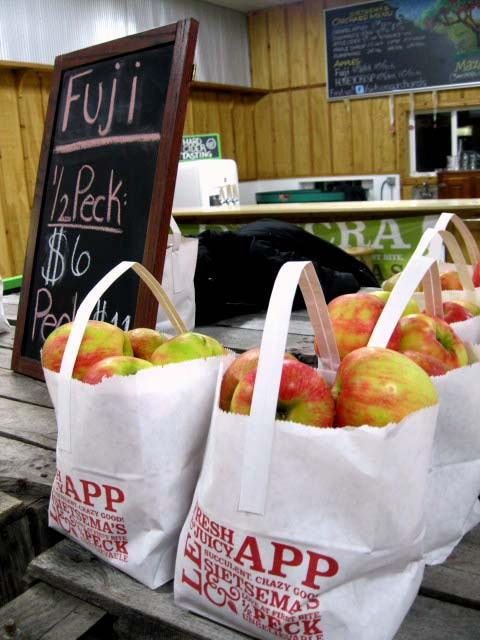Are there any other types of produce visible in this image besides apples? No other types of produce are visible in this image; the focus is solely on the bags of Fuji apples. 